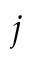<formula> <loc_0><loc_0><loc_500><loc_500>j</formula> 